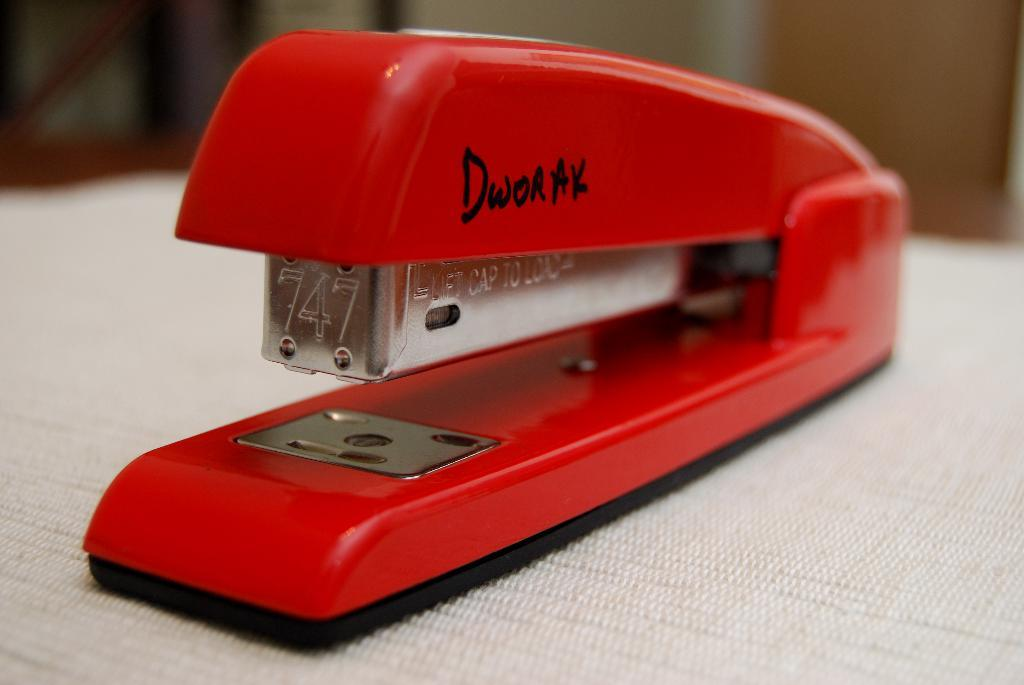What object can be seen in the image? There is a stapler in the image. What is the color of the stapler? The stapler is red in color. What type of skin is visible on the stapler in the image? There is no skin visible on the stapler in the image, as it is an inanimate object made of metal and plastic. 